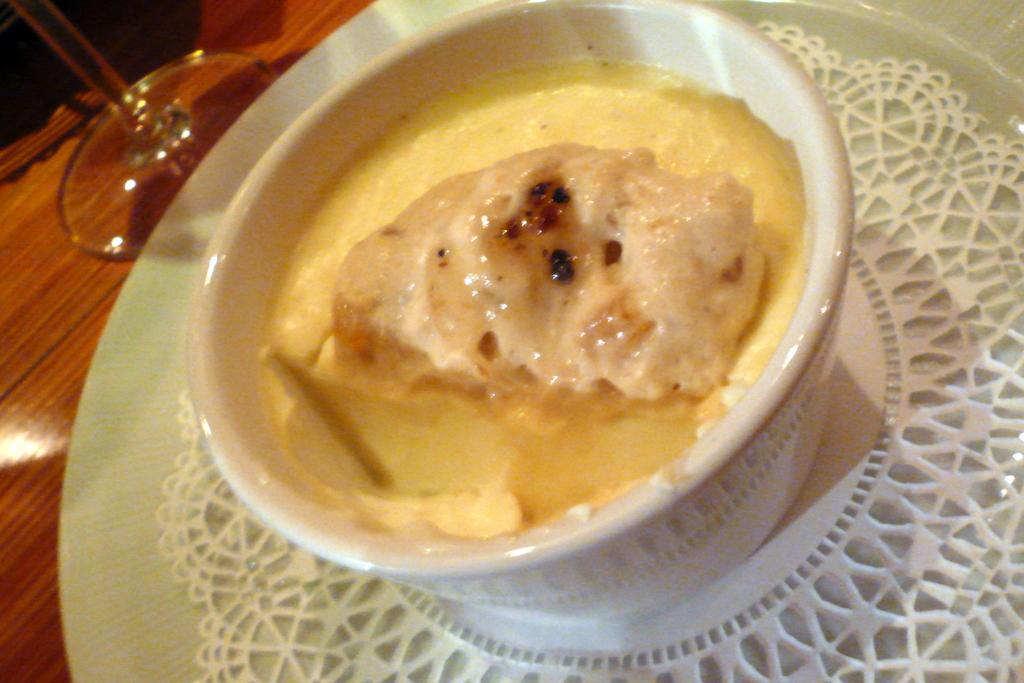What is in the bowl that is visible in the image? There is a bowl with a food item in the image. What other object can be seen on the table in the image? There is a glass placed on a table in the image. How many rabbits can be seen traveling on a journey in the image? There are no rabbits or journeys depicted in the image; it only features a bowl with a food item and a glass on a table. 